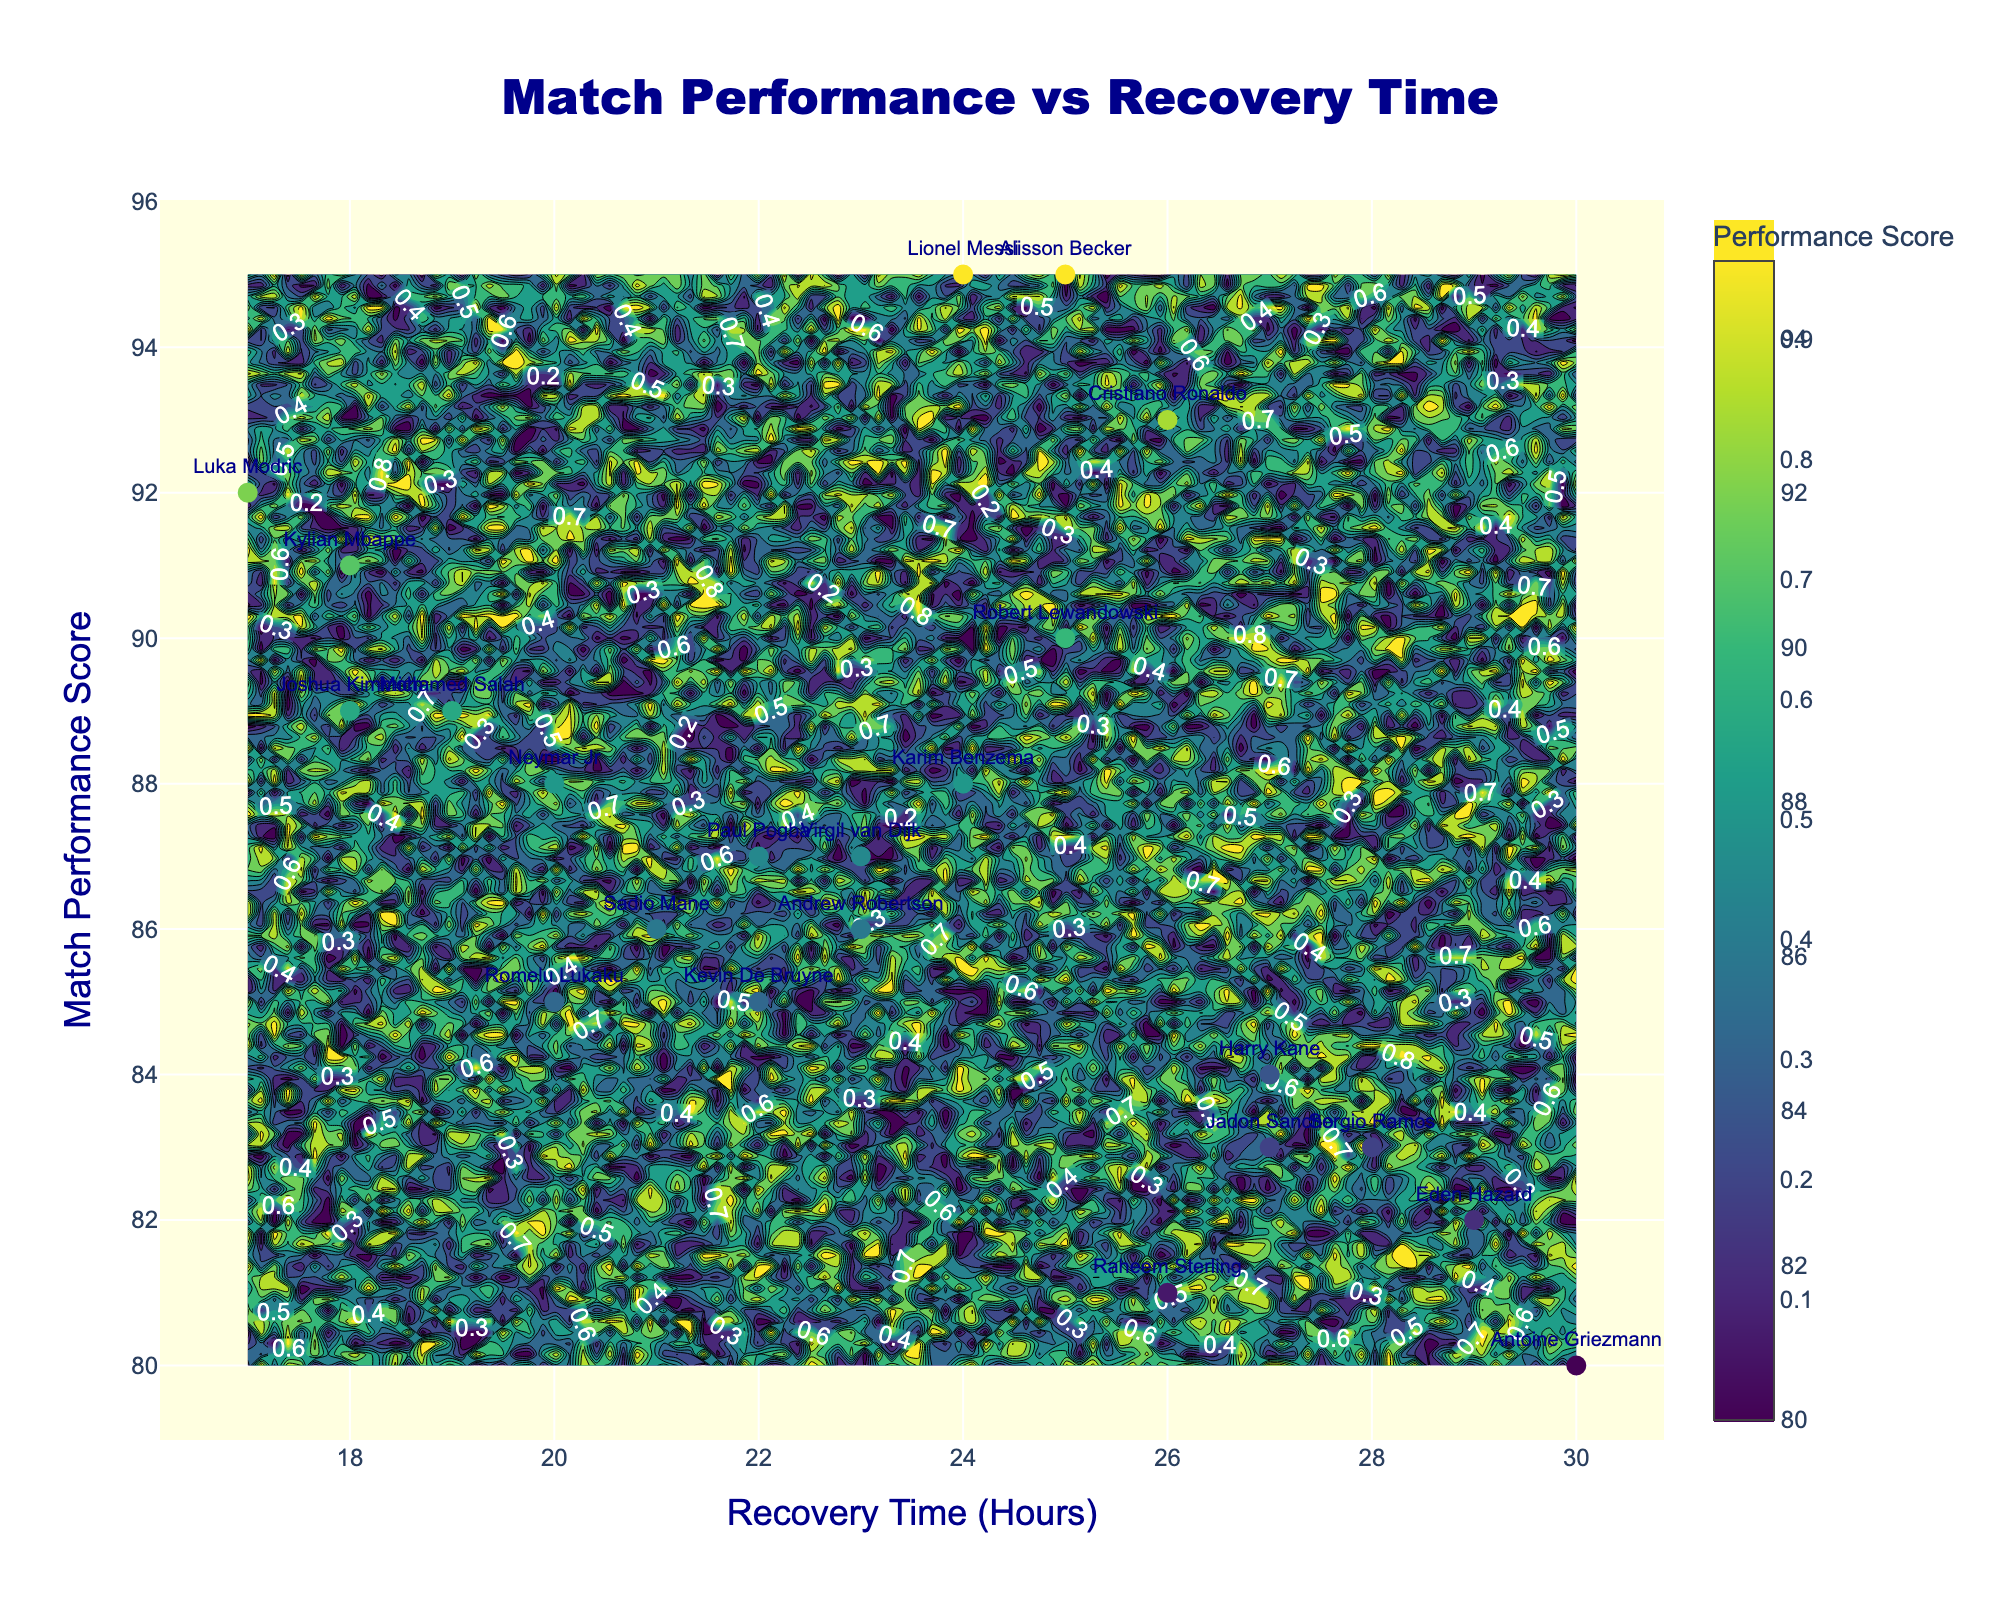What's the title of the plot? The title of the plot is written at the top center of the figure in large font size. It reads "Match Performance vs Recovery Time".
Answer: Match Performance vs Recovery Time How many players have their names labeled on the plot? Each data point on the plot represents a player, and there are corresponding text labels for each player. By counting the number of labels, we can find out there are 21 players.
Answer: 21 What is the Recovery Time range in hours? The x-axis represents the Recovery Time in hours. By looking at the minimum and maximum values on the x-axis, the range is from 17 to 30 hours.
Answer: 17 to 30 What's the Match Performance Score of the player with the shortest Recovery Time? The player with the shortest Recovery Time can be found by locating the leftmost point on the x-axis. Luka Modric has a Recovery Time of 17 hours and a Match Performance Score of 92.
Answer: 92 Who has the highest Match Performance Score and what is their Recovery Time? By finding the point with the highest y-value on the y-axis, we see Lionel Messi has the highest Match Performance Score. His Recovery Time is 24 hours.
Answer: Lionel Messi, 24 Which player has the longest Recovery Time and what is their Match Performance Score? The player with the longest Recovery Time is the rightmost point on the x-axis. Antoine Griezmann has a Recovery Time of 30 hours and a Match Performance Score of 80.
Answer: Antoine Griezmann, 80 Which players have the same Match Performance Score and what are their Recovery Times? A comparison on the y-axis shows that both Karim Benzema and Neymar Jr. have the same Match Performance Score of 88. Their respective Recovery Times are 24 and 20 hours.
Answer: Karim Benzema: 24, Neymar Jr: 20 What's the difference in Recovery Time between the players with the highest and lowest Match Performance Scores? The highest score is 95 (Lionel Messi and Alisson Becker) and the lowest is 80 (Antoine Griezmann). Their Recovery Times are 24 and 25 hours (Lionel Messi and Alisson Becker), and 30 hours (Antoine Griezmann). The differences are 6 and 5 hours.
Answer: 6, 5 Which player shows the best performance with a Recovery Time under 20 hours? We need to identify players with Recovery Times under 20 hours and then select the player with the highest Match Performance Score among them. Kylian Mbappe has a Recovery Time of 18 hours and a score of 91.
Answer: Kylian Mbappe What can you say about the relationship between Recovery Time and Match Performance Score based on the contour lines? Contour lines indicate the same value; we look for their general direction. If they are denser or closer together in a particular area, it suggests a steep gradient. The overall pattern should tell us correlation. The contour plot suggests there is no strong linear relationship between Recovery Time and Match Performance Score as the lines are scattered.
Answer: No strong linear relationship 